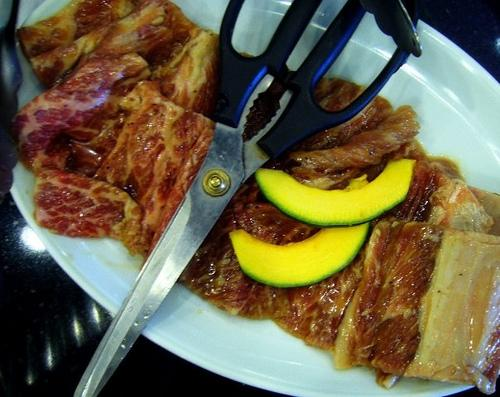Mention the key objects in the image and their colors. A black and silver pair of scissors, brown and red meat, a white plate, and yellow and green avocado slices are the key objects in the image. Write a description of the food presented and the objects in the foreground. A raw churrasco steak with yellow avocado slices and fatty portions sits on a white porcelain serving dish, with a pair of kitchen scissors prominently displayed on top. List the secondary elements of the image and describe their colors and positions. Light reflections on the black table and scissors blade, water droplets on the blade, and a section of the black counter are secondary elements in the image. Describe the scene using simple language for a child to understand. A plate has yummy meat, a fancy sandwich topping, and special scissors to cut things. The plate is on a big, black table. Provide a brief description of the primary elements seen in the image. A pair of black and silver scissors is placed on a plate filled with sliced beef, well-cooked short ribs, and yellow and green avocado slices. In a casual tone, describe the items in the image and their arrangement. Oh, there's a pair of kitchen scissors just chilling on a plate full of beef and avocados. The scissors got a black handle and cuttin' edges to open bottle caps too! Focus on the arrangement of the meat and accessories in the image. The image features well-cooked short ribs, sliced avocados, and a mango garnish, alongside a pair of scissors with black handles and steel toothed kitchen shears. Describe an unusual detail in the image without mentioning the main subjects. There are light reflections on the scissors blade, table surface, and water droplets on the blade, adding a subtle artistic touch to the scene. Highlight the unusual combination of objects in the image. There's an odd pairing of kitchen scissors on a plate filled with beef and avocado slices, a mix of practical tools and scrumptious food. Explain the position of the scissors and its features in the image. Scissors are placed on top of the meat with black handles, a silver bolt, toothed kitchen shears, and a bottle-opening section. 